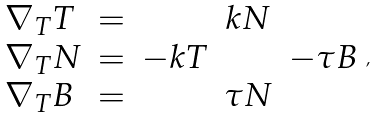<formula> <loc_0><loc_0><loc_500><loc_500>\begin{array} { l c c c c } \nabla _ { T } T & = & & k N & \\ \nabla _ { T } N & = & - k T & & - \tau B \\ \nabla _ { T } B & = & & \tau N & \end{array} ,</formula> 